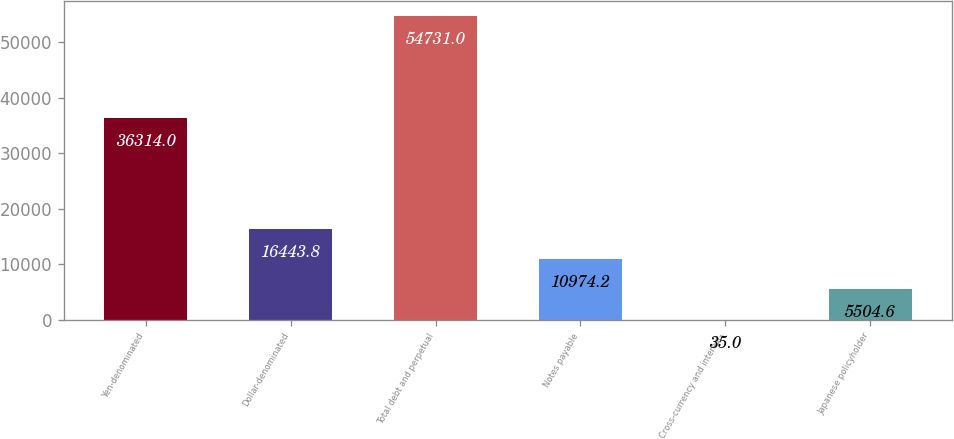Convert chart. <chart><loc_0><loc_0><loc_500><loc_500><bar_chart><fcel>Yen-denominated<fcel>Dollar-denominated<fcel>Total debt and perpetual<fcel>Notes payable<fcel>Cross-currency and interest-<fcel>Japanese policyholder<nl><fcel>36314<fcel>16443.8<fcel>54731<fcel>10974.2<fcel>35<fcel>5504.6<nl></chart> 